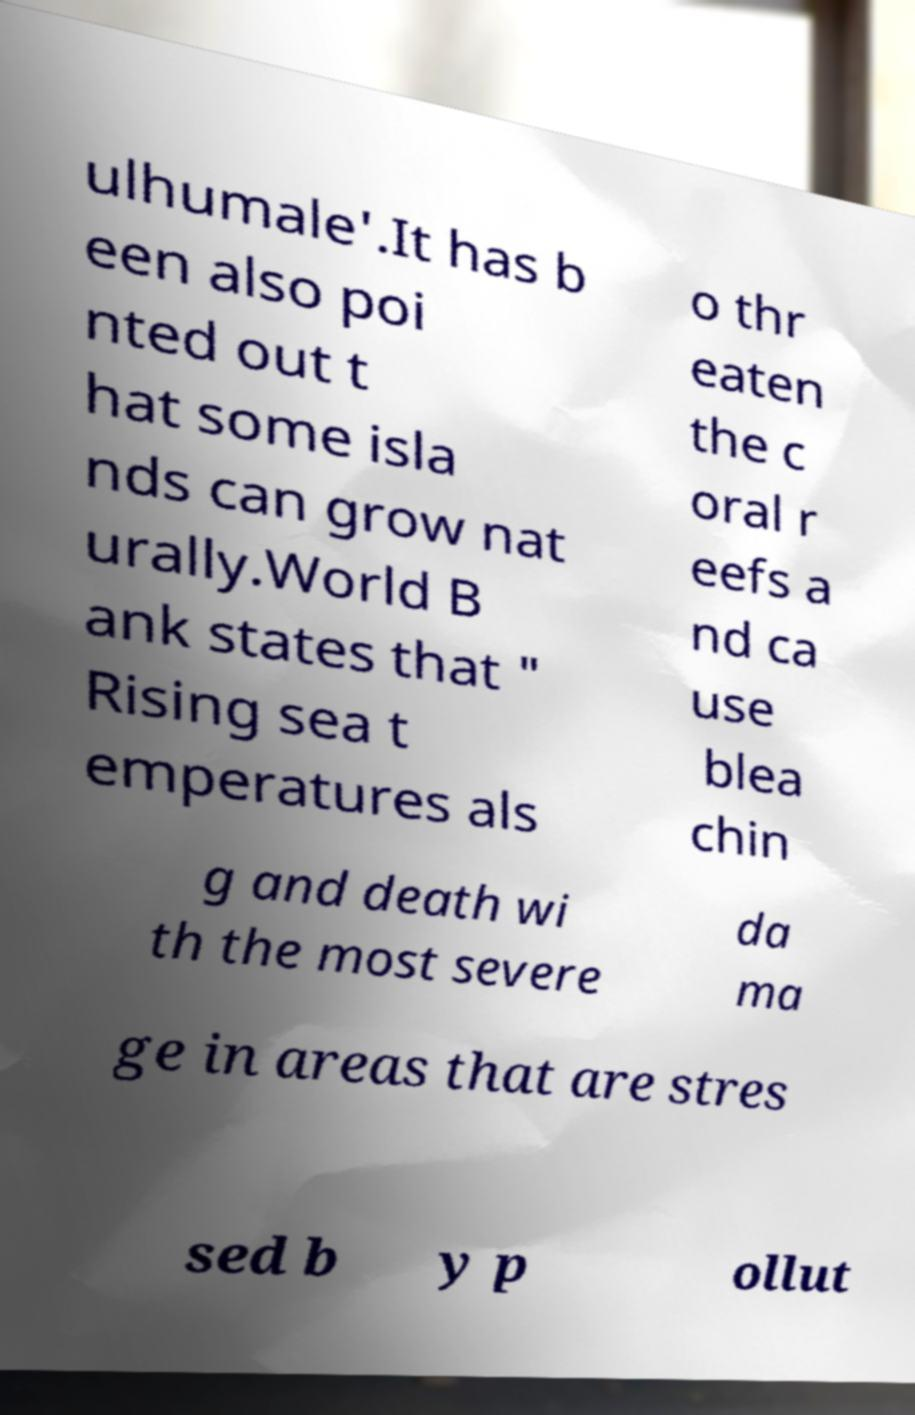There's text embedded in this image that I need extracted. Can you transcribe it verbatim? ulhumale'.It has b een also poi nted out t hat some isla nds can grow nat urally.World B ank states that " Rising sea t emperatures als o thr eaten the c oral r eefs a nd ca use blea chin g and death wi th the most severe da ma ge in areas that are stres sed b y p ollut 